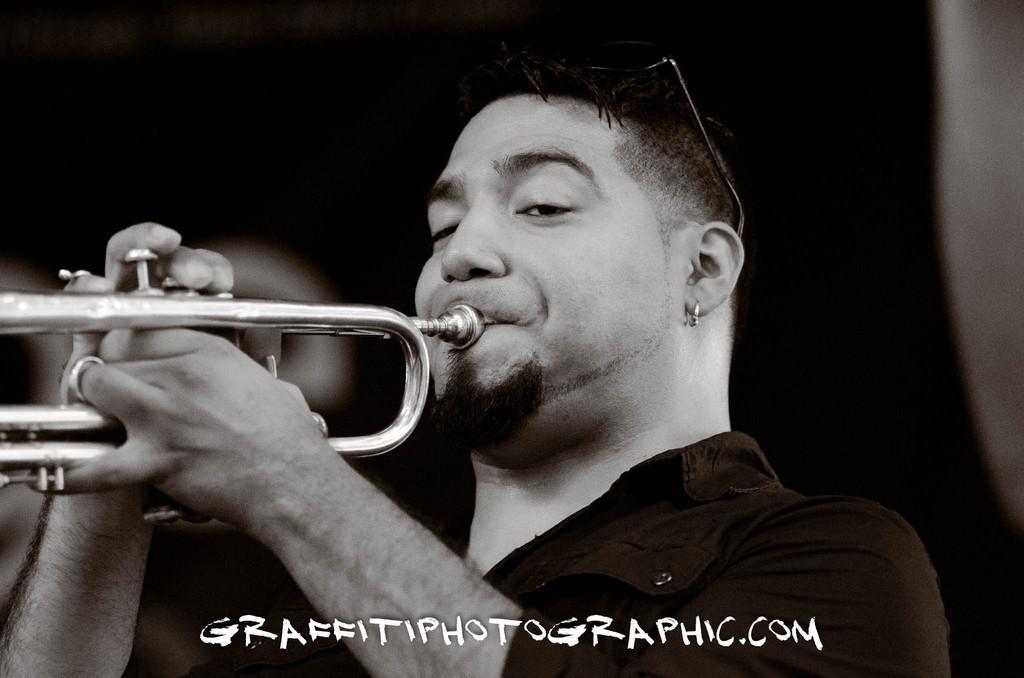Please provide a concise description of this image. There is a person in a t-shirt, holding a musical instrument with both hands and playing. And the background is dark in color. 